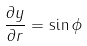Convert formula to latex. <formula><loc_0><loc_0><loc_500><loc_500>\frac { \partial y } { \partial r } = \sin \phi</formula> 